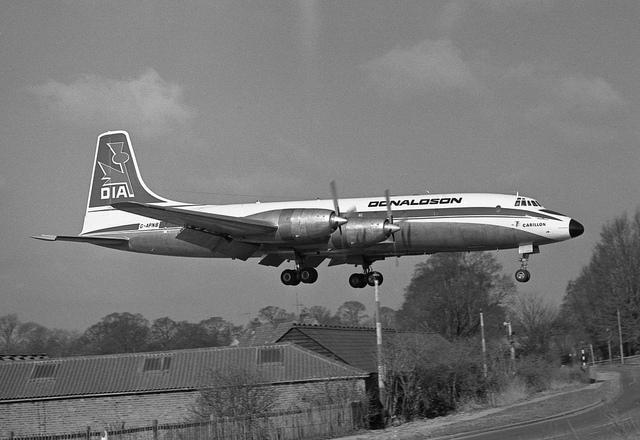Is this vehicle going up or down?
Concise answer only. Down. How many letter D are on the plane?
Keep it brief. 3. On the tail of the plane, what are the three letters written?
Quick response, please. Dia. Is the airplane flying?
Be succinct. Yes. 